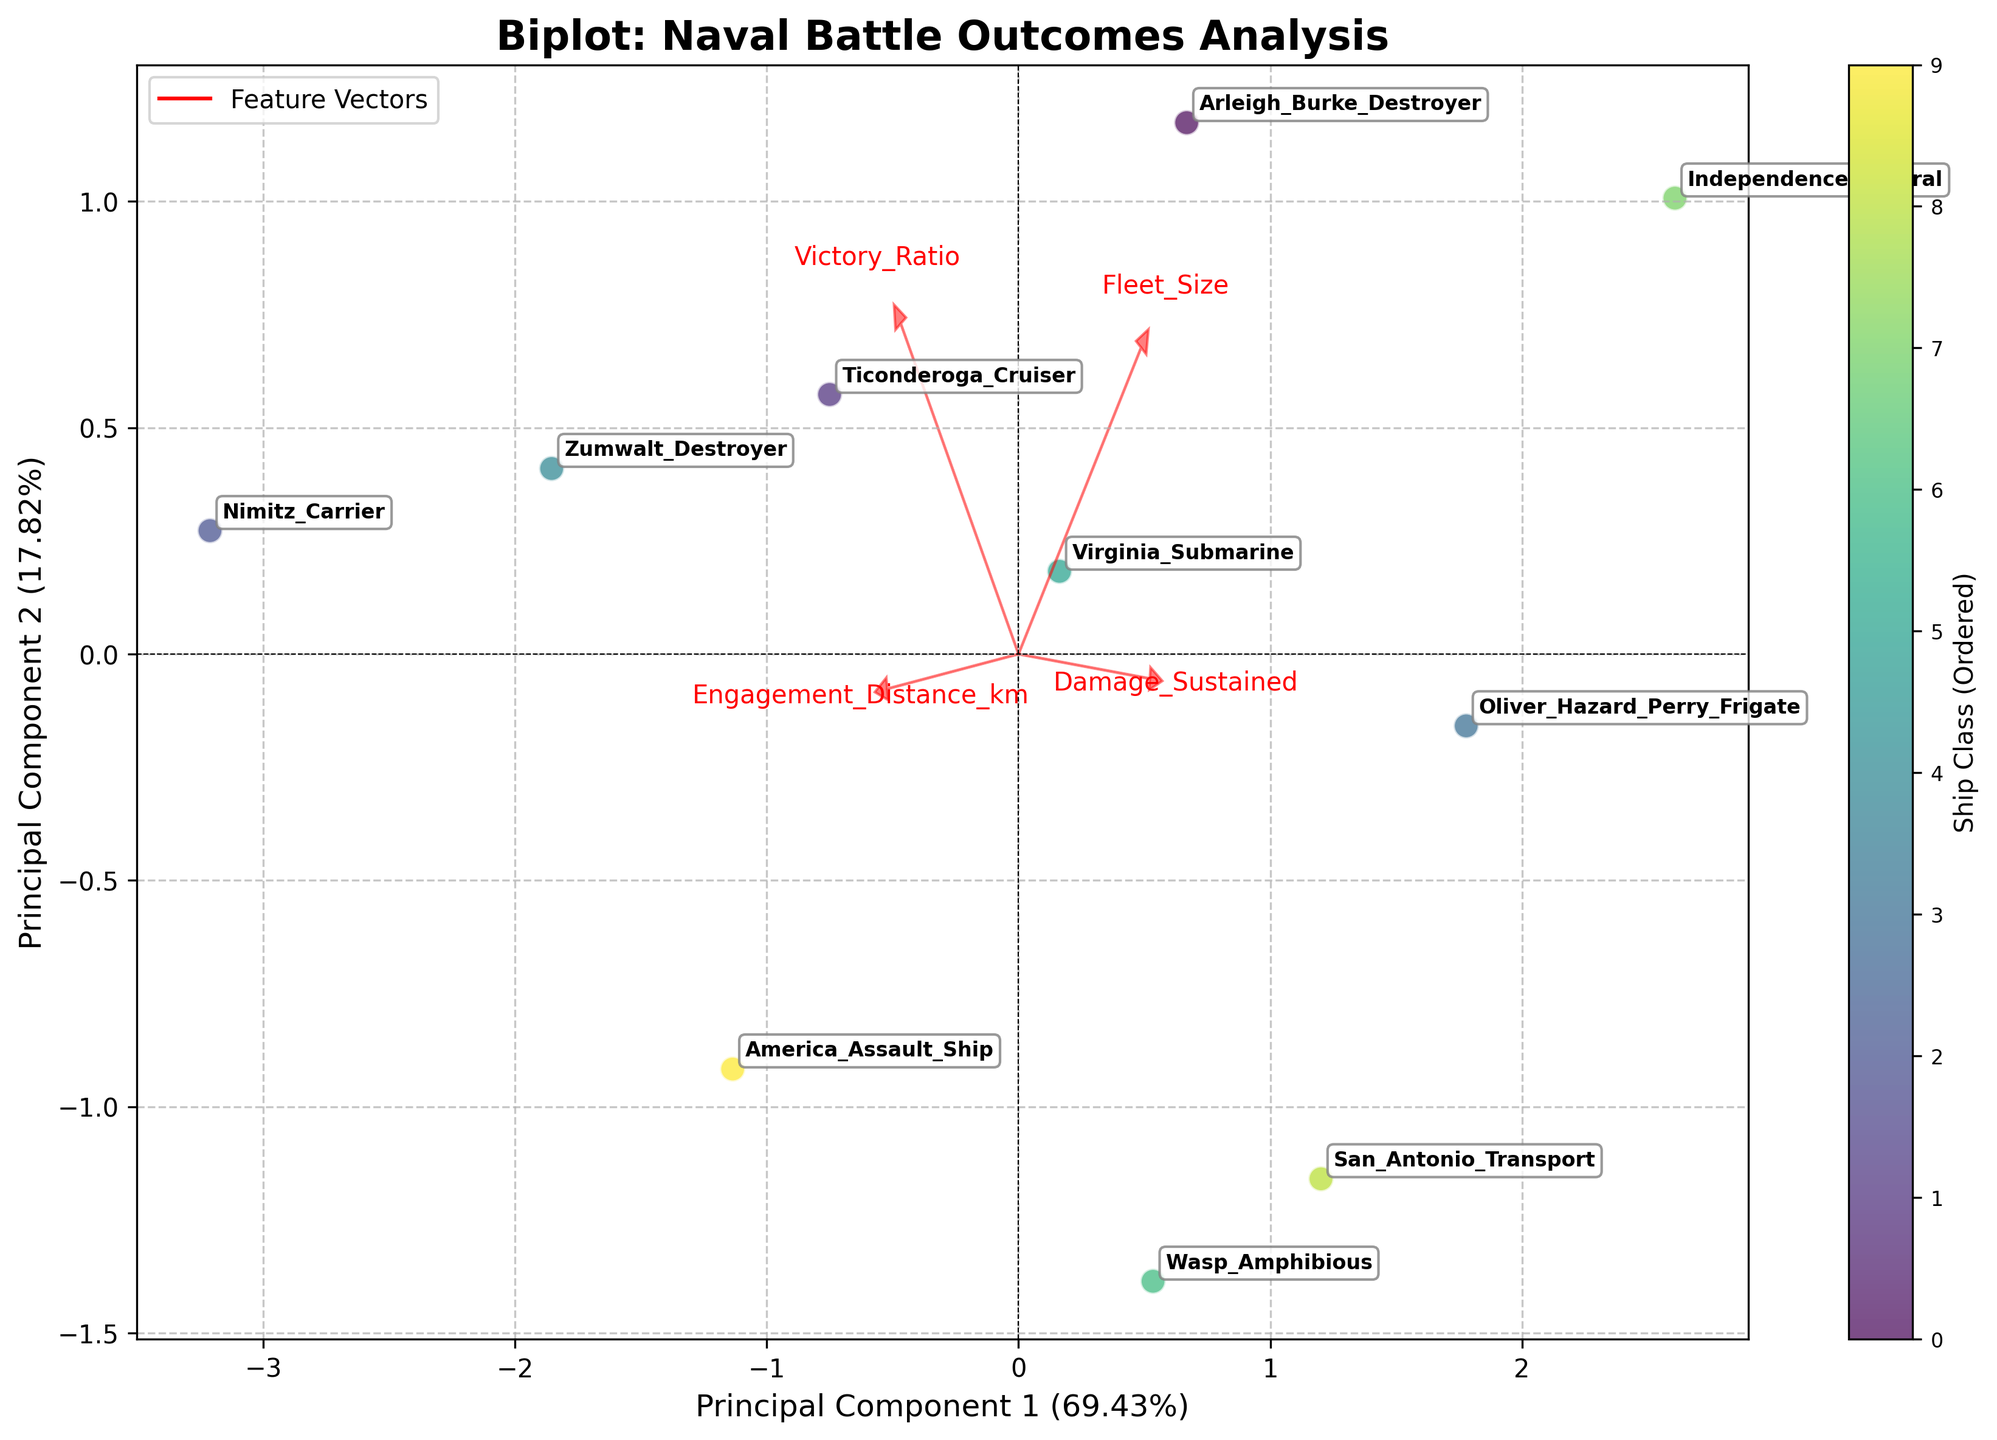What's the title of the plotted figure? Look at the top of the figure where the title is placed. The main title of the figure is usually found there.
Answer: "Biplot: Naval Battle Outcomes Analysis" Which two principal components are used in the X and Y axes? Check the labels on the X and Y axes. They typically indicate the principal components used, along with their explained variance ratio.
Answer: Principal Component 1 and Principal Component 2 Which ship class appears to have the highest principal component 1 value? Find the data point farthest to the right on the X-axis (Principal Component 1) and identify its label.
Answer: Nimitz Carrier How many ship classes are plotted in the figure? Count the number of unique data points (labels) represented in the figure.
Answer: 10 Which feature vector points most strongly in the direction of Victory Ratio? Look for the red arrows representing the feature vectors and the labels placed near the arrows. Identify the arrow with the label "Victory Ratio".
Answer: Victory_Ratio Based on the plotted data, which ship class sustains the most damage? Look for the data point nearest to the direction of the Damage_Sustained feature vector and identify its label.
Answer: Independence Littoral Between the Zumwalt Destroyer and Oliver Hazard Perry Frigate, which one has a higher Victory Ratio? Compare their distances from the origin to the end of the Victory_Ratio feature vector. The closer to the end of the vector, the higher the Victory Ratio.
Answer: Zumwalt Destroyer Which feature vector is closest to the Principal Component 1 axis and what does it represent? Identify the red arrow that aligns most closely with the Principal Component 1 axis and read its label.
Answer: Fleet_Size Can you find a ship class that seems to balance both a high Victory Ratio and low Damage Sustained? Identify the data point close to the directions of both the Victory_Ratio feature vector and opposite the Damage_Sustained vector.
Answer: Nimitz Carrier What can you infer about the Fleet Size and Engagement Distance vectors in terms of their correlation? Check the angle between the Fleet_Size and Engagement_Distance vectors. If they are close to 180 degrees, they're negatively correlated; close to 0 degrees, they're positively correlated.
Answer: They are close to orthogonal, indicating little to no correlation 